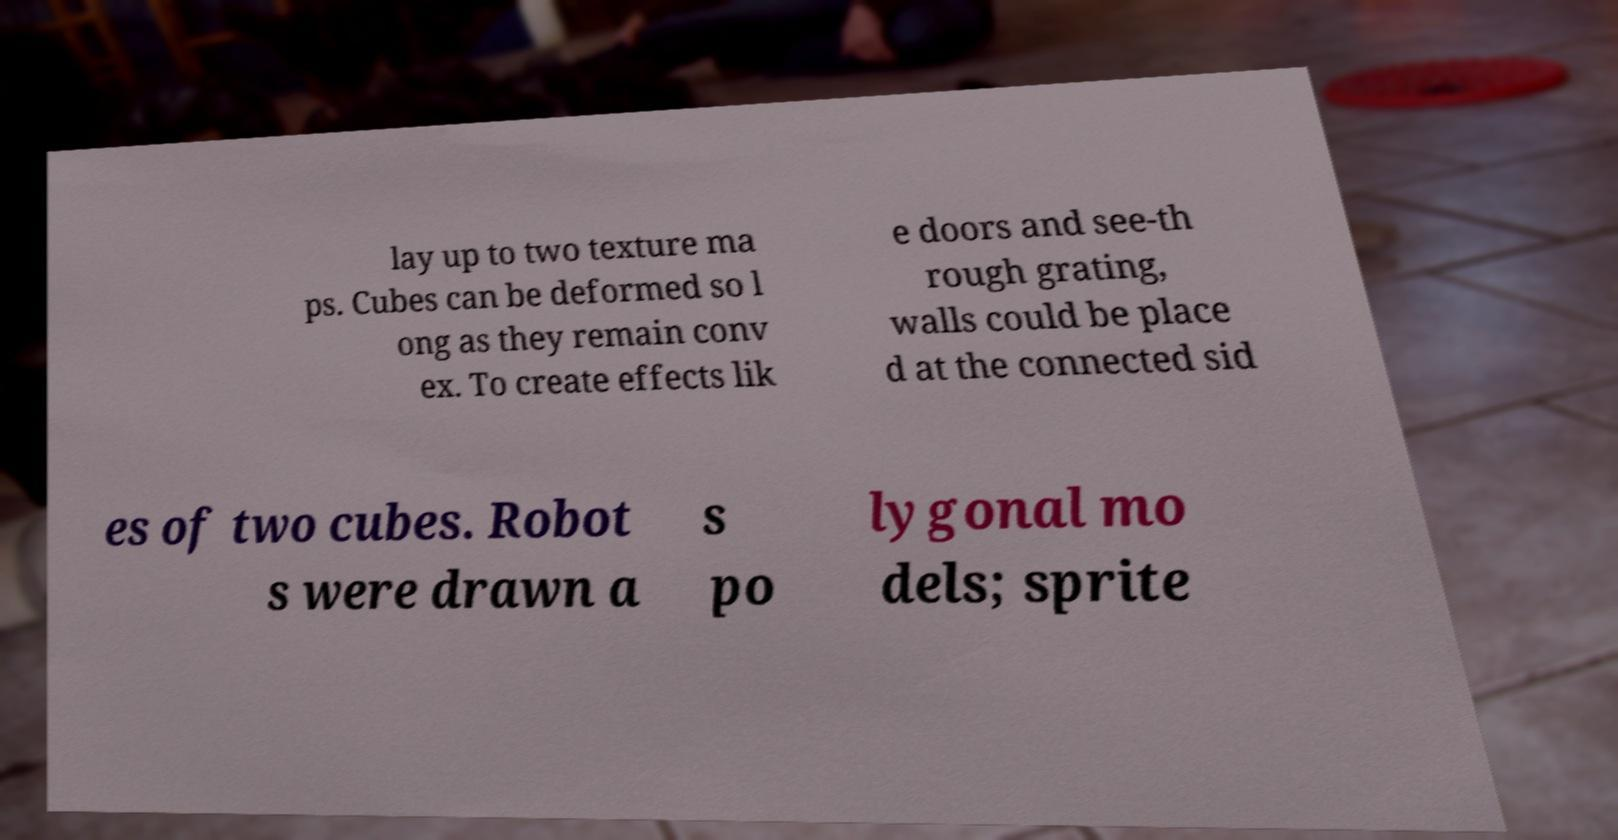Could you extract and type out the text from this image? lay up to two texture ma ps. Cubes can be deformed so l ong as they remain conv ex. To create effects lik e doors and see-th rough grating, walls could be place d at the connected sid es of two cubes. Robot s were drawn a s po lygonal mo dels; sprite 